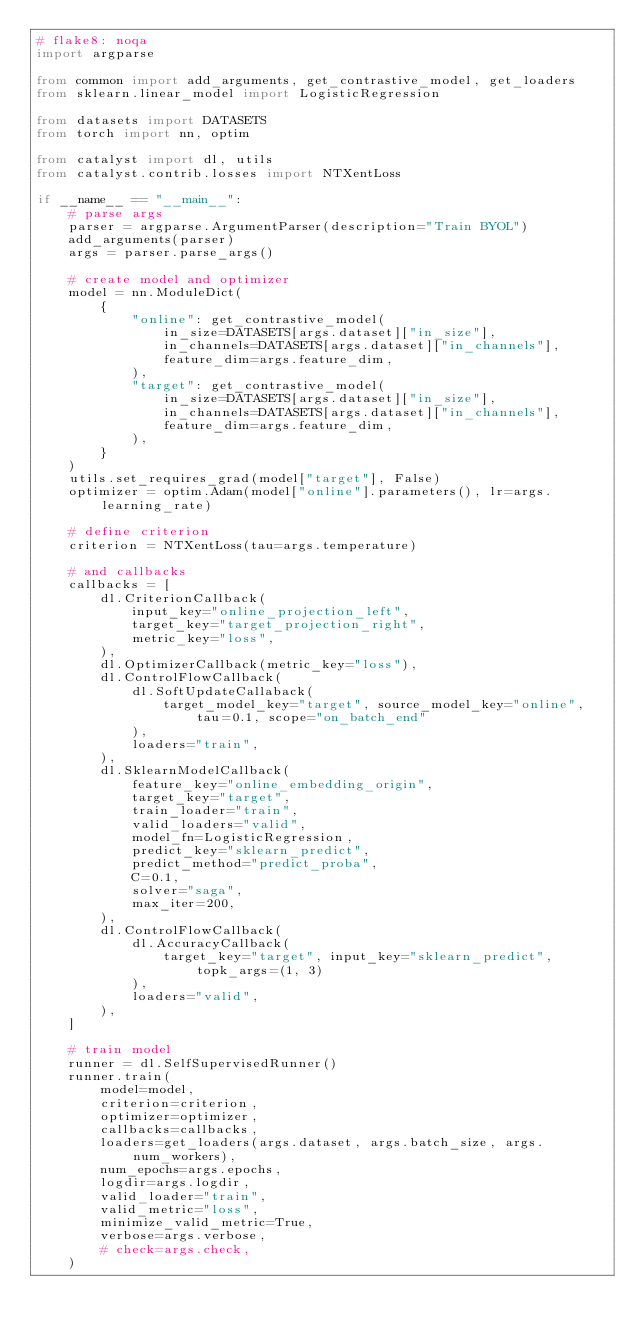Convert code to text. <code><loc_0><loc_0><loc_500><loc_500><_Python_># flake8: noqa
import argparse

from common import add_arguments, get_contrastive_model, get_loaders
from sklearn.linear_model import LogisticRegression

from datasets import DATASETS
from torch import nn, optim

from catalyst import dl, utils
from catalyst.contrib.losses import NTXentLoss

if __name__ == "__main__":
    # parse args
    parser = argparse.ArgumentParser(description="Train BYOL")
    add_arguments(parser)
    args = parser.parse_args()

    # create model and optimizer
    model = nn.ModuleDict(
        {
            "online": get_contrastive_model(
                in_size=DATASETS[args.dataset]["in_size"],
                in_channels=DATASETS[args.dataset]["in_channels"],
                feature_dim=args.feature_dim,
            ),
            "target": get_contrastive_model(
                in_size=DATASETS[args.dataset]["in_size"],
                in_channels=DATASETS[args.dataset]["in_channels"],
                feature_dim=args.feature_dim,
            ),
        }
    )
    utils.set_requires_grad(model["target"], False)
    optimizer = optim.Adam(model["online"].parameters(), lr=args.learning_rate)

    # define criterion
    criterion = NTXentLoss(tau=args.temperature)

    # and callbacks
    callbacks = [
        dl.CriterionCallback(
            input_key="online_projection_left",
            target_key="target_projection_right",
            metric_key="loss",
        ),
        dl.OptimizerCallback(metric_key="loss"),
        dl.ControlFlowCallback(
            dl.SoftUpdateCallaback(
                target_model_key="target", source_model_key="online", tau=0.1, scope="on_batch_end"
            ),
            loaders="train",
        ),
        dl.SklearnModelCallback(
            feature_key="online_embedding_origin",
            target_key="target",
            train_loader="train",
            valid_loaders="valid",
            model_fn=LogisticRegression,
            predict_key="sklearn_predict",
            predict_method="predict_proba",
            C=0.1,
            solver="saga",
            max_iter=200,
        ),
        dl.ControlFlowCallback(
            dl.AccuracyCallback(
                target_key="target", input_key="sklearn_predict", topk_args=(1, 3)
            ),
            loaders="valid",
        ),
    ]

    # train model
    runner = dl.SelfSupervisedRunner()
    runner.train(
        model=model,
        criterion=criterion,
        optimizer=optimizer,
        callbacks=callbacks,
        loaders=get_loaders(args.dataset, args.batch_size, args.num_workers),
        num_epochs=args.epochs,
        logdir=args.logdir,
        valid_loader="train",
        valid_metric="loss",
        minimize_valid_metric=True,
        verbose=args.verbose,
        # check=args.check,
    )
</code> 